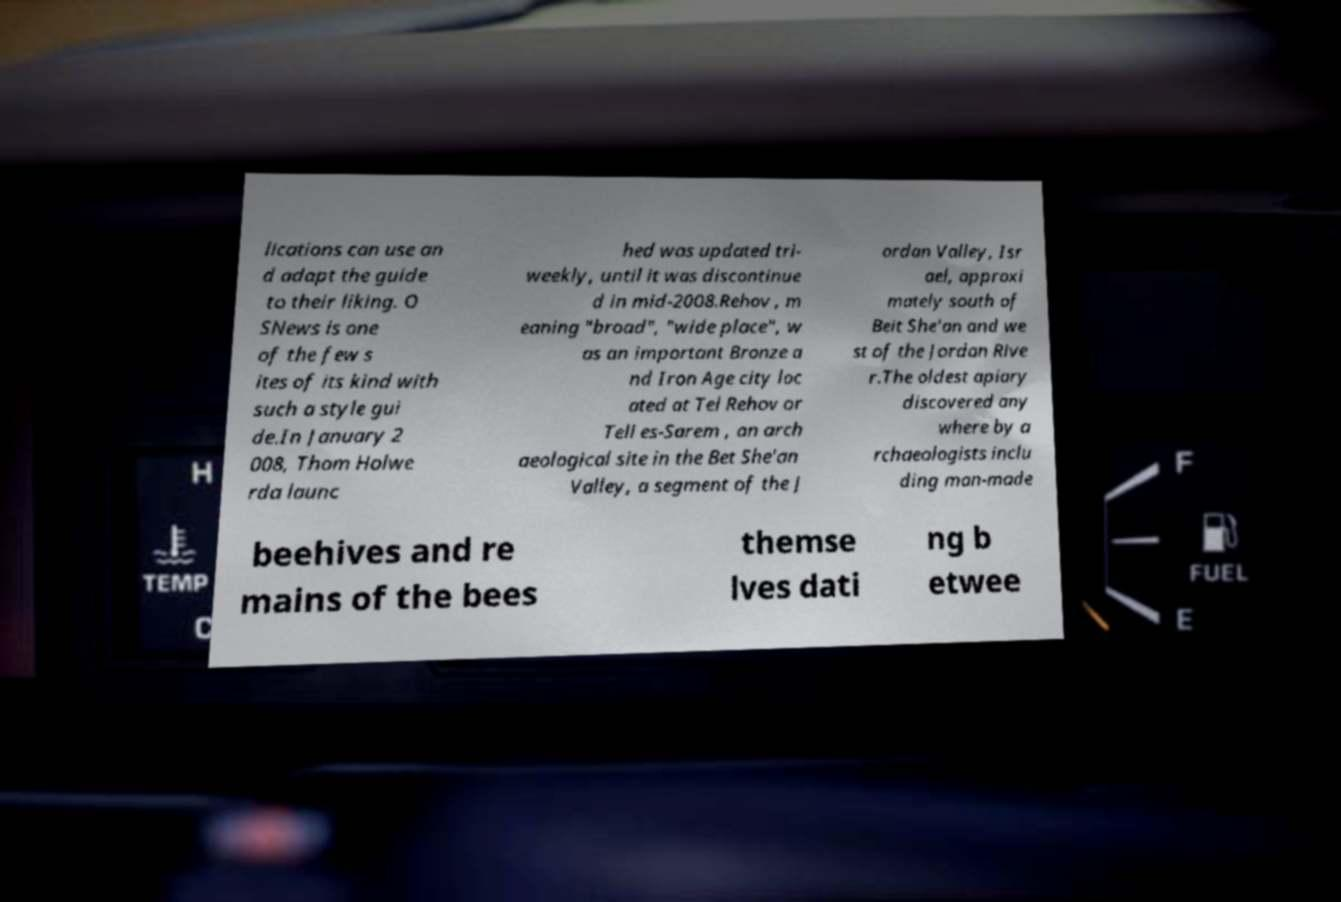Please read and relay the text visible in this image. What does it say? lications can use an d adapt the guide to their liking. O SNews is one of the few s ites of its kind with such a style gui de.In January 2 008, Thom Holwe rda launc hed was updated tri- weekly, until it was discontinue d in mid-2008.Rehov , m eaning "broad", "wide place", w as an important Bronze a nd Iron Age city loc ated at Tel Rehov or Tell es-Sarem , an arch aeological site in the Bet She'an Valley, a segment of the J ordan Valley, Isr ael, approxi mately south of Beit She'an and we st of the Jordan Rive r.The oldest apiary discovered any where by a rchaeologists inclu ding man-made beehives and re mains of the bees themse lves dati ng b etwee 